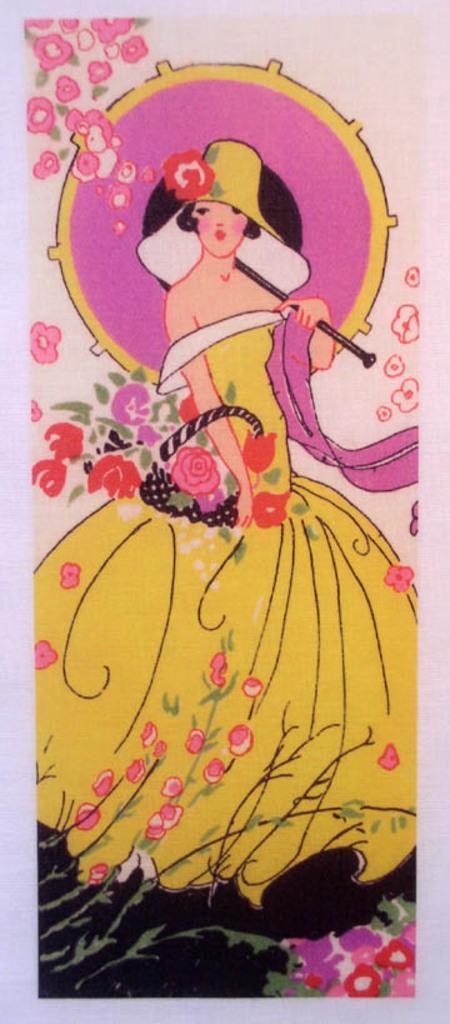Please provide a concise description of this image. In this image there is a painting, there is a woman standing, she is holding an object, there are flowers, the background of the image is pink in color. 